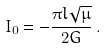Convert formula to latex. <formula><loc_0><loc_0><loc_500><loc_500>I _ { 0 } = - \frac { \pi l \sqrt { \mu } } { 2 G } \, .</formula> 